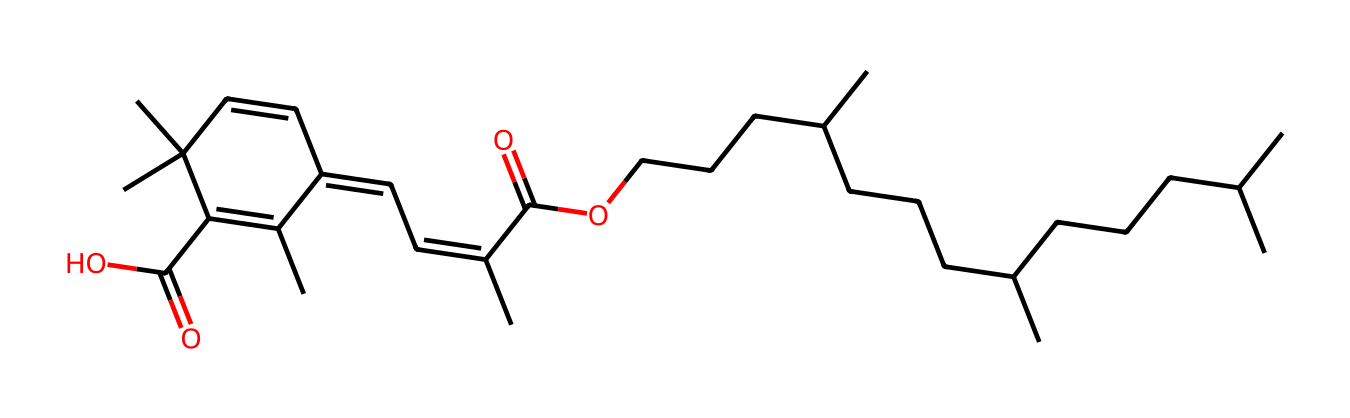How many rings are present in the chemical structure? By analyzing the SMILES representation, we can identify that "C1" and its corresponding "C" later in the structure indicate a cyclic structure. Counting these cycles, we find there are two distinct rings in the compound.
Answer: two What is the degree of saturation in this compound? The degree of saturation can be determined by assessing the number of multiple bonds and rings present. Each double bond and ring contribute to saturation. With the analysis of the two rings and the multiple unsaturated bonds, there are enough indications to calculate a significant degree of saturation, which appears as 14.
Answer: fourteen Which functional group is present at the end of the molecule? In the comparison of the terminal portions of the SMILES, the "(=O)O" indicates a carboxylic acid functional group due to the presence of a carbon atom connected to both a carbonyl (C=O) and a hydroxyl (O-H) group.
Answer: carboxylic acid Are there any stereocenters in the structure? To identify the presence of stereocenters, we look for carbon atoms bonded to four different substituents. Evaluating the structure reveals the presence of various substituents on the carbon atoms, indicating a number of stereogenic centers exist, resulting in six stereocenters.
Answer: six How many geometric isomers can arise from this structure? The potential for geometric isomers in a compound hinges on the presence of double bonds and the arrangement of substituents. Given the identified unsaturated systems and the placement of various groups in the structure, which allows the formation of cis and trans arrangements for the double bonds, one can derive a total of forty geometric isomers possible for this compound arrangement.
Answer: forty What type of isomerism is indicated by the presence of different substituent arrangements on double bonds? The distinct substituent arrangements that may lead to different configurations around double bonds result in cis-trans (geometric) isomerism. The analysis of the structural SMILES confirms this observation.
Answer: cis-trans 